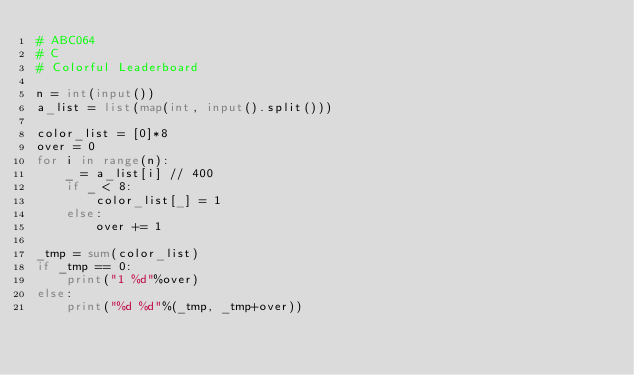Convert code to text. <code><loc_0><loc_0><loc_500><loc_500><_Python_># ABC064
# C
# Colorful Leaderboard

n = int(input())
a_list = list(map(int, input().split()))

color_list = [0]*8
over = 0
for i in range(n):
    _ = a_list[i] // 400
    if _ < 8:
        color_list[_] = 1
    else:
        over += 1

_tmp = sum(color_list)
if _tmp == 0:
    print("1 %d"%over)
else:
    print("%d %d"%(_tmp, _tmp+over))</code> 